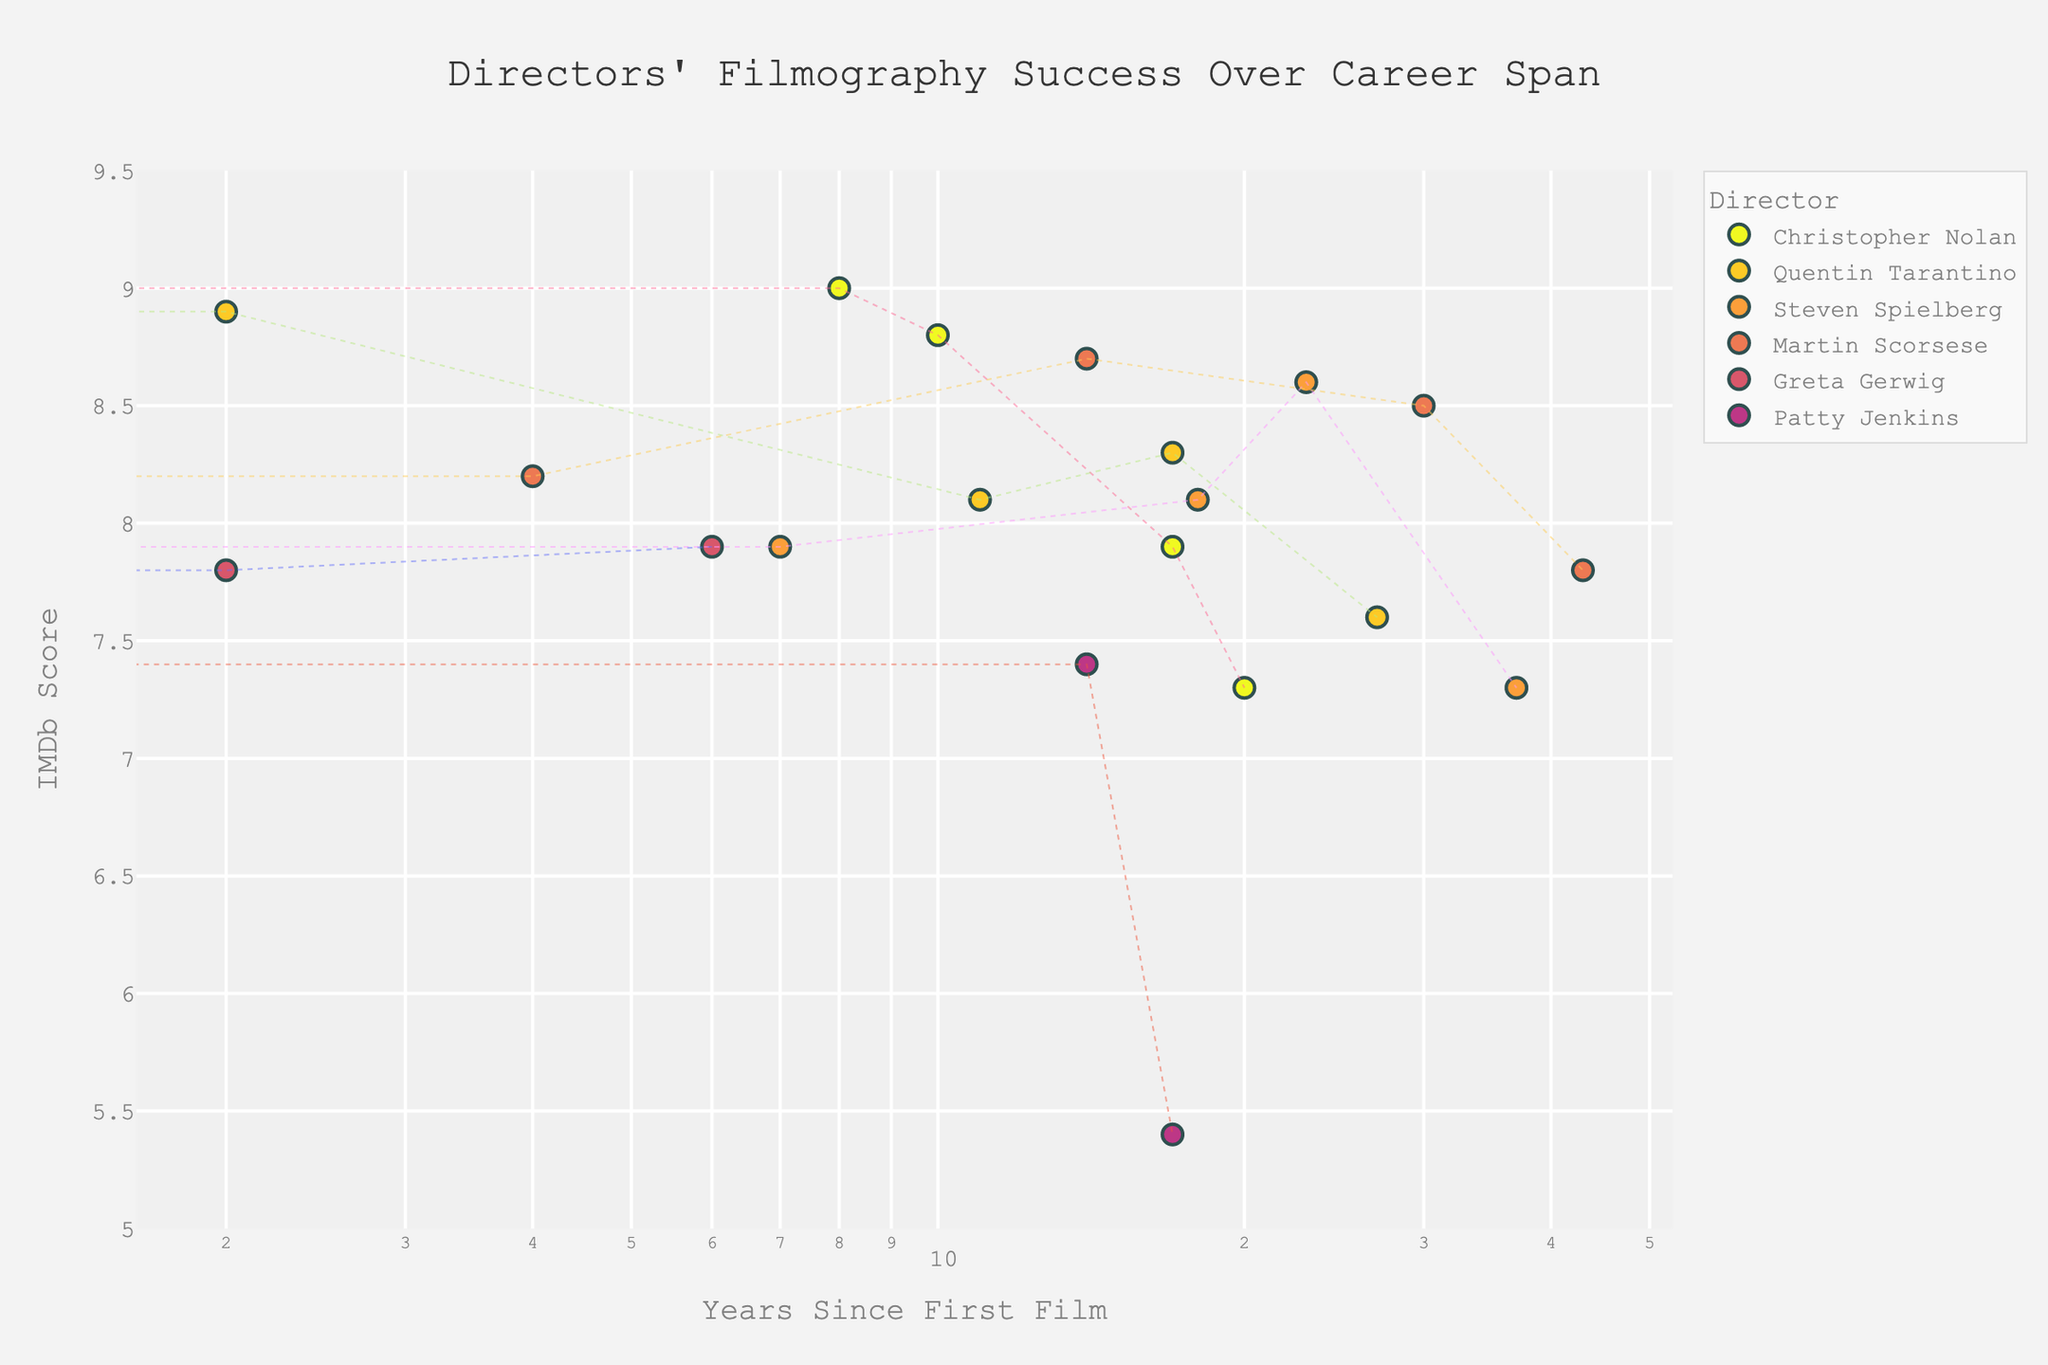How many directors' data points are depicted in the figure? Count the unique directors listed in the dataset. The directors are Christopher Nolan, Quentin Tarantino, Steven Spielberg, Martin Scorsese, Greta Gerwig, and Patty Jenkins, making a total of six directors.
Answer: 6 What is the title of the plot? The title is displayed prominently at the top of the figure.
Answer: Directors' Filmography Success Over Career Span Which director has the highest IMDb score for a film, and what is the score? Look for the highest point along the Y-axis (IMDb Score). Hovering over or checking the legend data reveals Christopher Nolan with "The Dark Knight" having a score of 9.0.
Answer: Christopher Nolan, 9.0 For Steven Spielberg, what is the range of IMDb scores for his films shown in the figure? Identify Spielberg's films and note their IMDb Scores: Jaws (8.1), E.T. the Extra-Terrestrial (7.9), Jurassic Park (8.1), Saving Private Ryan (8.6), Lincoln (7.3). The highest is 8.6, and the lowest is 7.3.
Answer: 7.3 to 8.6 How does the trend line of Quentin Tarantino's films compare with that of Patty Jenkins? Look at the scatterplot lines for both directors. Tarantino's trend shows a generally stable high rating, while Jenkins's starts similarly but declines with "Wonder Woman 1984".
Answer: Tarantino's is stable, Jenkins's declines How many years since their first film has Christopher Nolan's highest-rated film been released? Check the horizontal (log) axis for Nolan's data points and find the coordinates of the highest IMDb Score (9.0 for "The Dark Knight"). "The Dark Knight" (2008) came 8 years after "Memento" (2000).
Answer: 8 years Compare the average IMDb score of Greta Gerwig and Patty Jenkins. Who has the higher average score? Calculate Gerwig's average: (7.4 + 7.8 + 7.9)/3 = 7.7. Jenkins's average: (7.3 + 7.4 + 5.4)/3 ≈ 6.7. Compare the two averages.
Answer: Greta Gerwig Which director has the least variability in IMDb scores over their career? Examine the vertical spread of each director's points: Martin Scorsese’s scores appear the least spread out (Taxi Driver 8.2, Raging Bull 8.2, Goodfellas 8.7, The Departed 8.5, The Irishman 7.8).
Answer: Martin Scorsese What log scale value corresponds to "0" Years Since First Film? In a log scale, zero is undefined. Look closely at the axis labels to infer the value. Most plots represent the smallest positive real number. Here it will be between 1 and 2.
Answer: 1 Which director debuted earliest, and what was their first film? Find the earliest "Year" value in the dataset and the corresponding director: Steven Spielberg with "Jaws" (1975).
Answer: Steven Spielberg, Jaws 